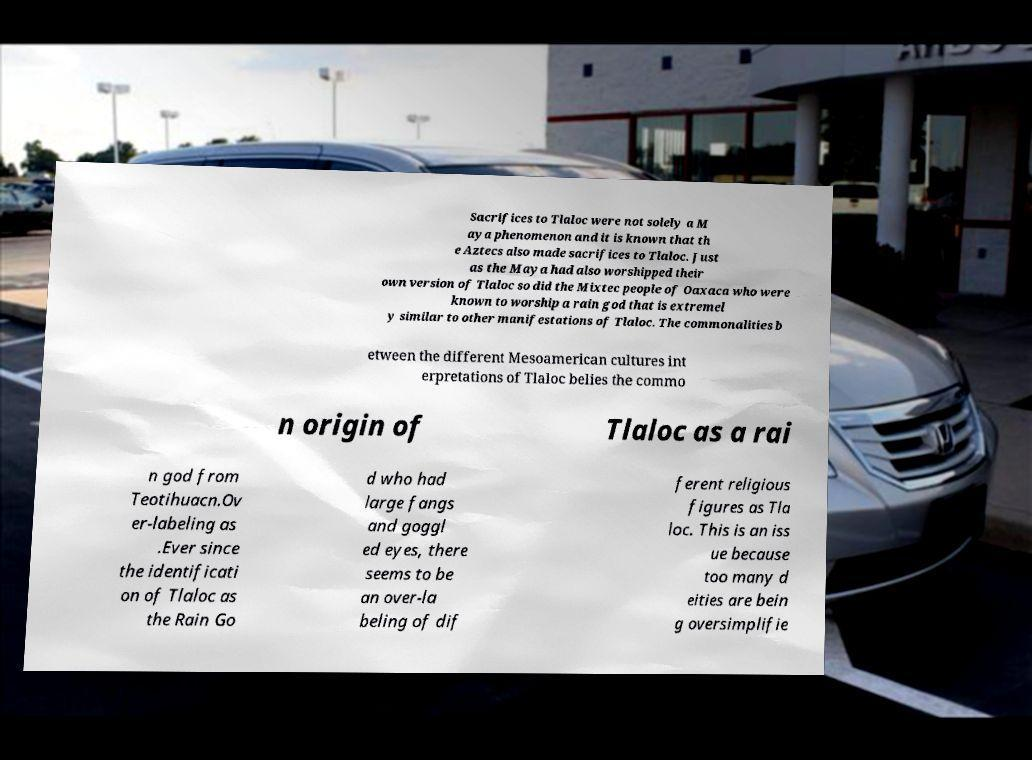Can you read and provide the text displayed in the image?This photo seems to have some interesting text. Can you extract and type it out for me? Sacrifices to Tlaloc were not solely a M aya phenomenon and it is known that th e Aztecs also made sacrifices to Tlaloc. Just as the Maya had also worshipped their own version of Tlaloc so did the Mixtec people of Oaxaca who were known to worship a rain god that is extremel y similar to other manifestations of Tlaloc. The commonalities b etween the different Mesoamerican cultures int erpretations of Tlaloc belies the commo n origin of Tlaloc as a rai n god from Teotihuacn.Ov er-labeling as .Ever since the identificati on of Tlaloc as the Rain Go d who had large fangs and goggl ed eyes, there seems to be an over-la beling of dif ferent religious figures as Tla loc. This is an iss ue because too many d eities are bein g oversimplifie 